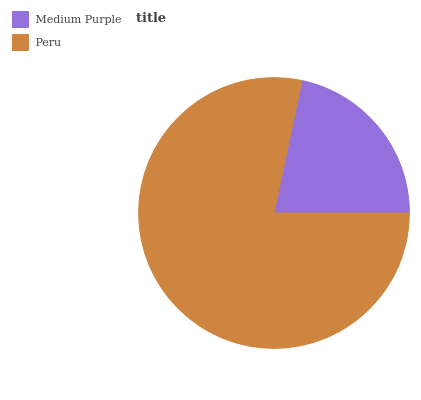Is Medium Purple the minimum?
Answer yes or no. Yes. Is Peru the maximum?
Answer yes or no. Yes. Is Peru the minimum?
Answer yes or no. No. Is Peru greater than Medium Purple?
Answer yes or no. Yes. Is Medium Purple less than Peru?
Answer yes or no. Yes. Is Medium Purple greater than Peru?
Answer yes or no. No. Is Peru less than Medium Purple?
Answer yes or no. No. Is Peru the high median?
Answer yes or no. Yes. Is Medium Purple the low median?
Answer yes or no. Yes. Is Medium Purple the high median?
Answer yes or no. No. Is Peru the low median?
Answer yes or no. No. 